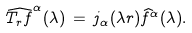Convert formula to latex. <formula><loc_0><loc_0><loc_500><loc_500>\widehat { T _ { r } f } ^ { \alpha } ( \lambda ) \, = \, j _ { \alpha } ( \lambda r ) \widehat { f } ^ { \alpha } ( \lambda ) .</formula> 